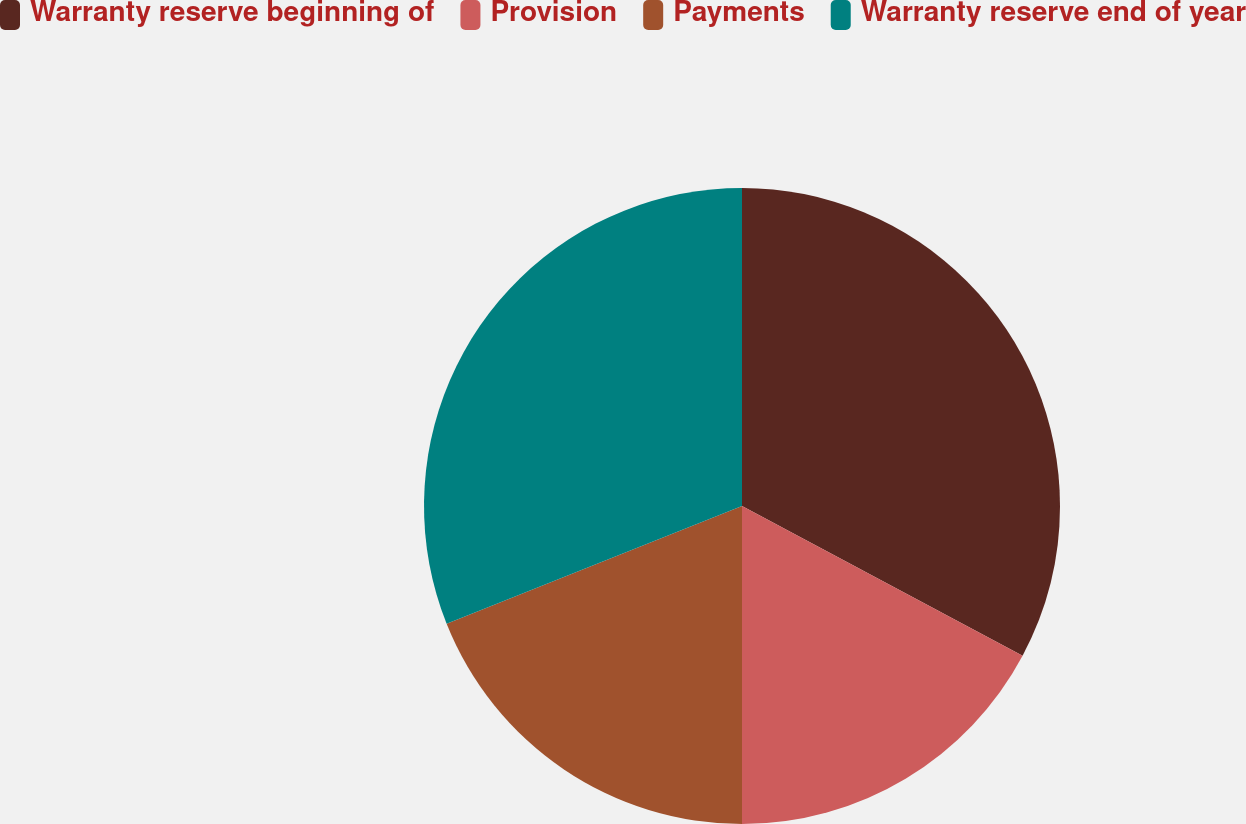<chart> <loc_0><loc_0><loc_500><loc_500><pie_chart><fcel>Warranty reserve beginning of<fcel>Provision<fcel>Payments<fcel>Warranty reserve end of year<nl><fcel>32.8%<fcel>17.2%<fcel>18.96%<fcel>31.04%<nl></chart> 